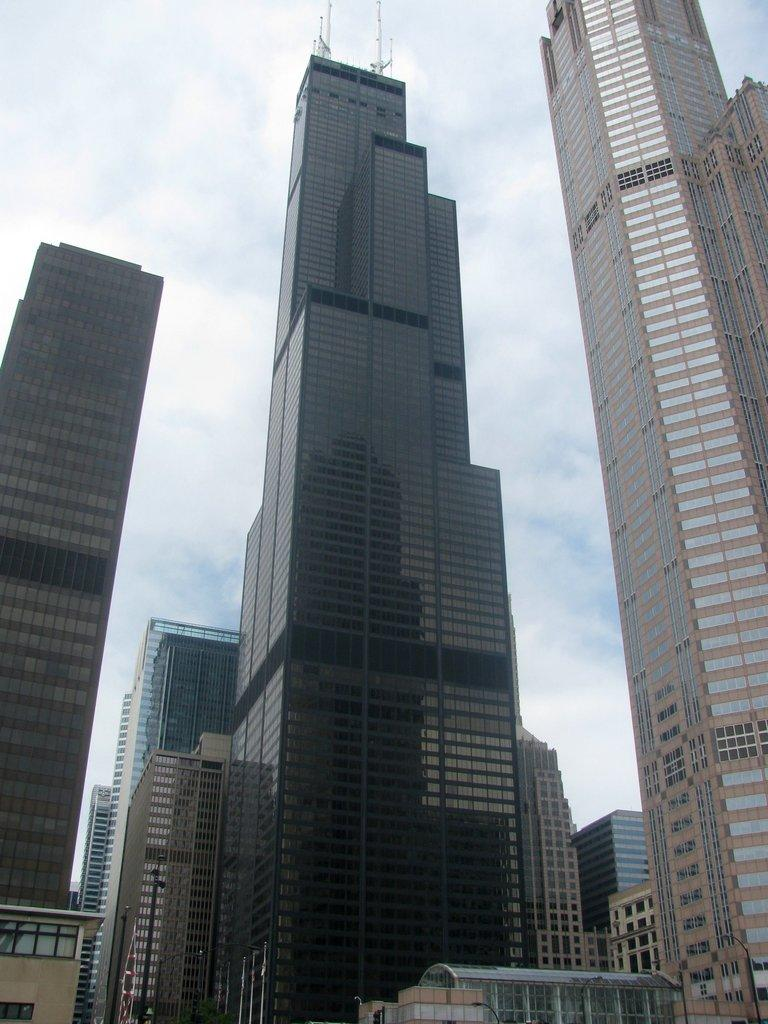What structures are visible in the image? There are buildings in the image. What can be seen in the sky in the background of the image? There are clouds in the sky in the background of the image. What type of society is depicted on the coast in the image? There is no society or coast present in the image; it features buildings and clouds in the sky. 